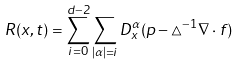Convert formula to latex. <formula><loc_0><loc_0><loc_500><loc_500>R ( x , t ) = \sum _ { i = 0 } ^ { d - 2 } \sum _ { | \alpha | = i } D ^ { \alpha } _ { x } ( p - \triangle ^ { - 1 } \nabla \cdot f )</formula> 